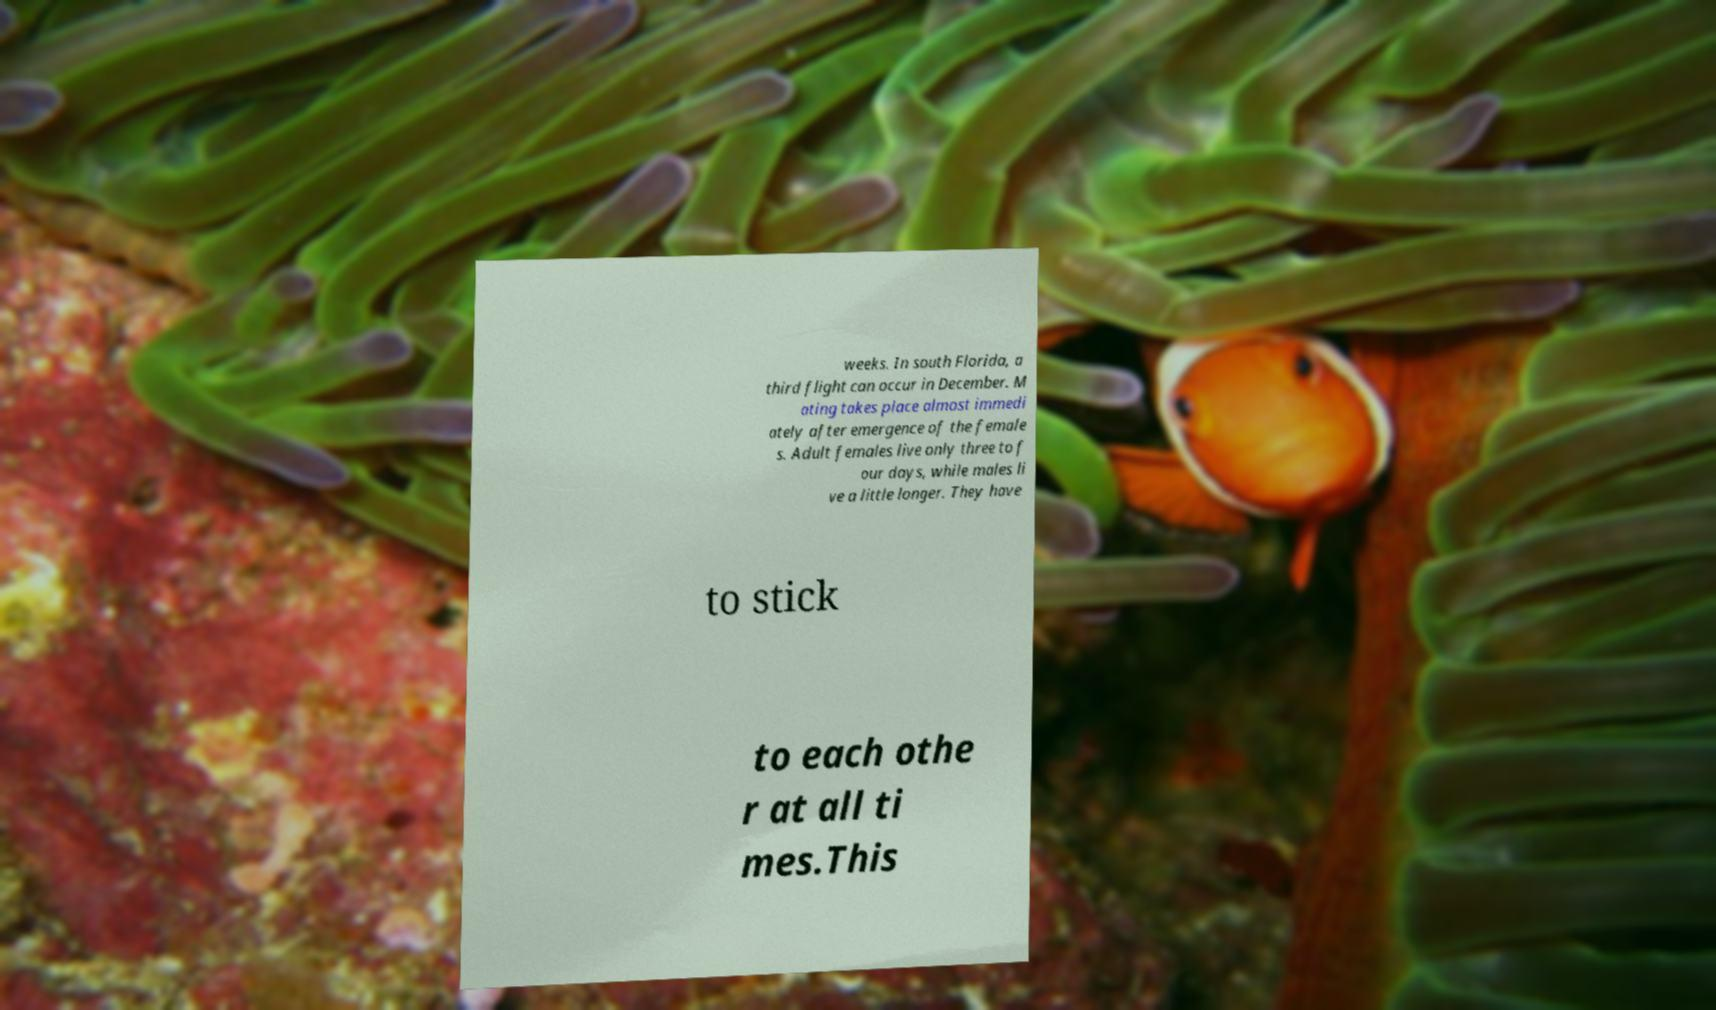There's text embedded in this image that I need extracted. Can you transcribe it verbatim? weeks. In south Florida, a third flight can occur in December. M ating takes place almost immedi ately after emergence of the female s. Adult females live only three to f our days, while males li ve a little longer. They have to stick to each othe r at all ti mes.This 